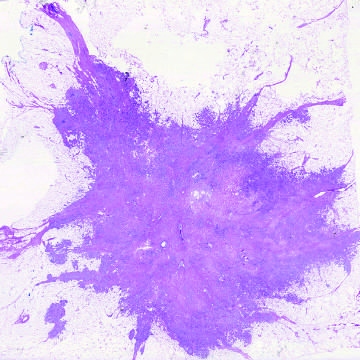does the injurious stimulus illustrate the invasion of breast stroma and fat by nests and cords of tumor cells?
Answer the question using a single word or phrase. No 